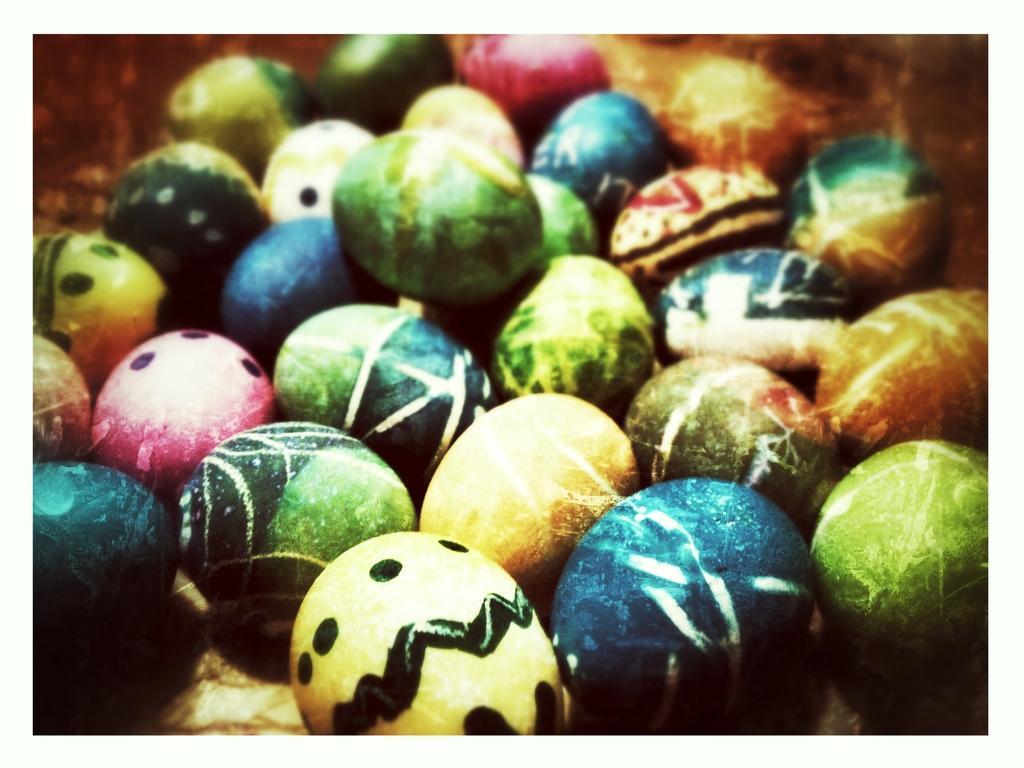In one or two sentences, can you explain what this image depicts? In this picture we can see colorful eggs. 